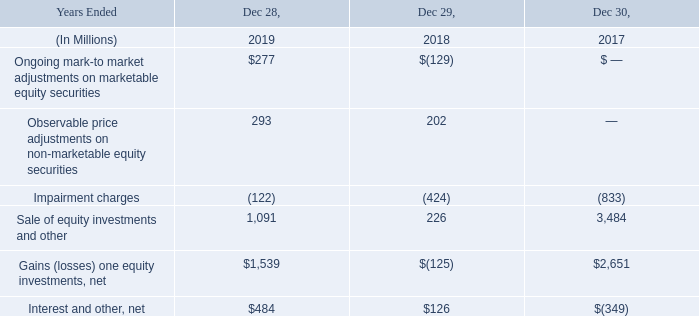GAINS (LOSSES) ON EQUITY INVESTMENTS AND INTEREST AND OTHER, NET
GAINS (LOSSES) ON EQUITY INVESTMENTS, NET
Ongoing mark-to-market net gains and losses reported in 2019 and 2018 were primarily driven by ASML Holding N.V. (ASML) and Cloudera Inc. (Cloudera). During 2019 we sold our equity investment in ASML.
In 2019, we recognized $293 million in observable price adjustments primarily from one investment.
During 2018, we recognized an impairment charge of $290 million in our equity method investment in IMFT. During 2017, we recognized impairment charges in our investments of Cloudera for $278 million and Unisoc for $308 million.
Major drivers of sales of equity investments and other in 2019 were dividends of $632 million from McAfee and a gain of $107 million from our sale of our non-controlling interest in IMFT. In 2017, we recognized $3.4 billion in realized gains on sales of a portion of our interest in ASML.
INTEREST AND OTHER, NET
We recognized a higher net gain in interest and other in 2019 compared to 2018, primarily due to lower loss on debt conversions and larger divestiture gains in 2019 compared to 2018.
We recognized a net gain in interest and other in 2018 compared to a net loss in 2017, primarily due to lower losses on debt conversions, higher assets under construction resulting in more capitalized interest, and larger divestiture gains in 2018 compared to 2017.
What were the main drivers for the net gains and losses in ongoing mark-to-market in 2019 and 2018? Ongoing mark-to-market net gains and losses reported in 2019 and 2018 were primarily driven by asml holding n.v. (asml) and cloudera inc. (cloudera). What were the main reasons for a higher net gain in interest and other in 2019 compared to 2018? Higher net gain in interest and other in 2019 compared to 2018, primarily due to lower loss on debt conversions and larger divestiture gains in 2019 compared to 2018. What were the main reasons for a net gain in interest and other in 2018 compared to a net loss in 2017? A net gain in interest and other in 2018 compared to a net loss in 2017, primarily due to lower losses on debt conversions, higher assets under construction resulting in more capitalized interest, and larger divestiture gains in 2018 compared to 2017. What is the proportion of equity method investment in IMFT in impairment charge in 2018?
Answer scale should be: percent. 290 / 424
Answer: 68.4. What is the proportion of dividends from McAfee in sales of equity investments and other in 2019?
Answer scale should be: percent. 632 / 1,091
Answer: 57.93. What is the percentage change in gains (losses) on equity investments, net from 2017 to 2019?
Answer scale should be: percent. (1,539 - 2,651) / 2,651
Answer: -41.95. 